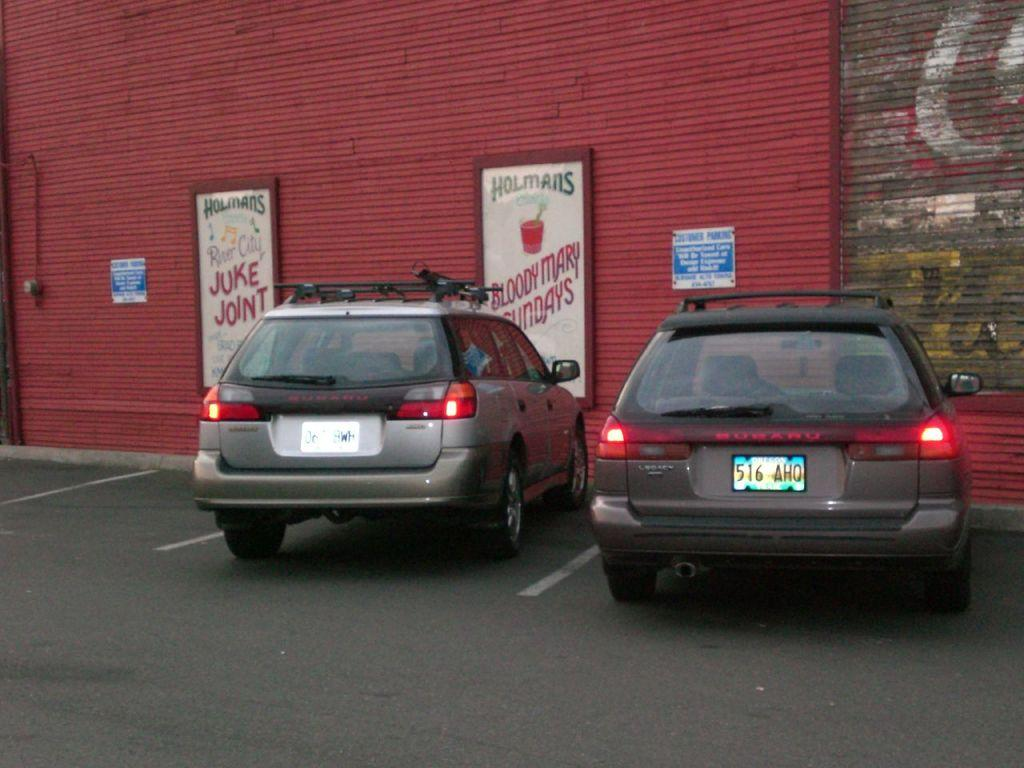<image>
Write a terse but informative summary of the picture. Advertisements for Holmans are on a wall in a car park. 